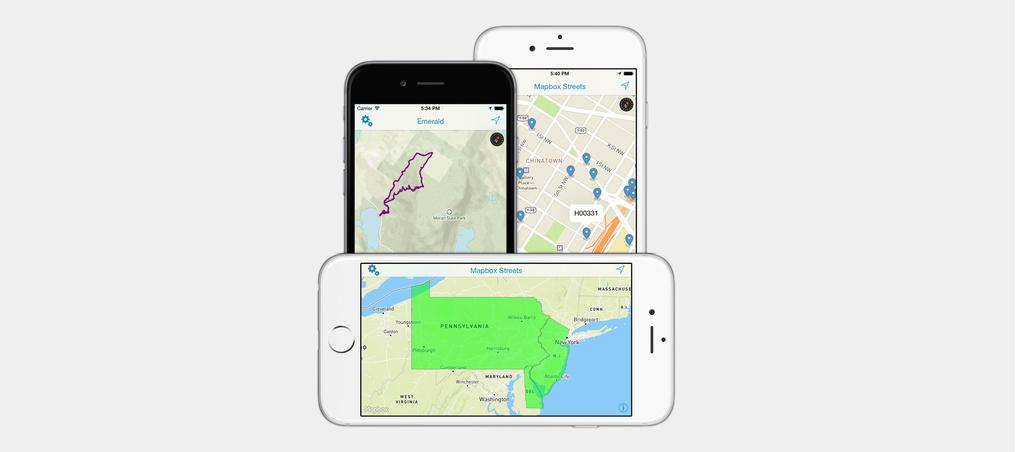<image>
Relay a brief, clear account of the picture shown. Two white cell phones showing the Mapbox Streets app and and one black cell phone showing an Emerald map app. 